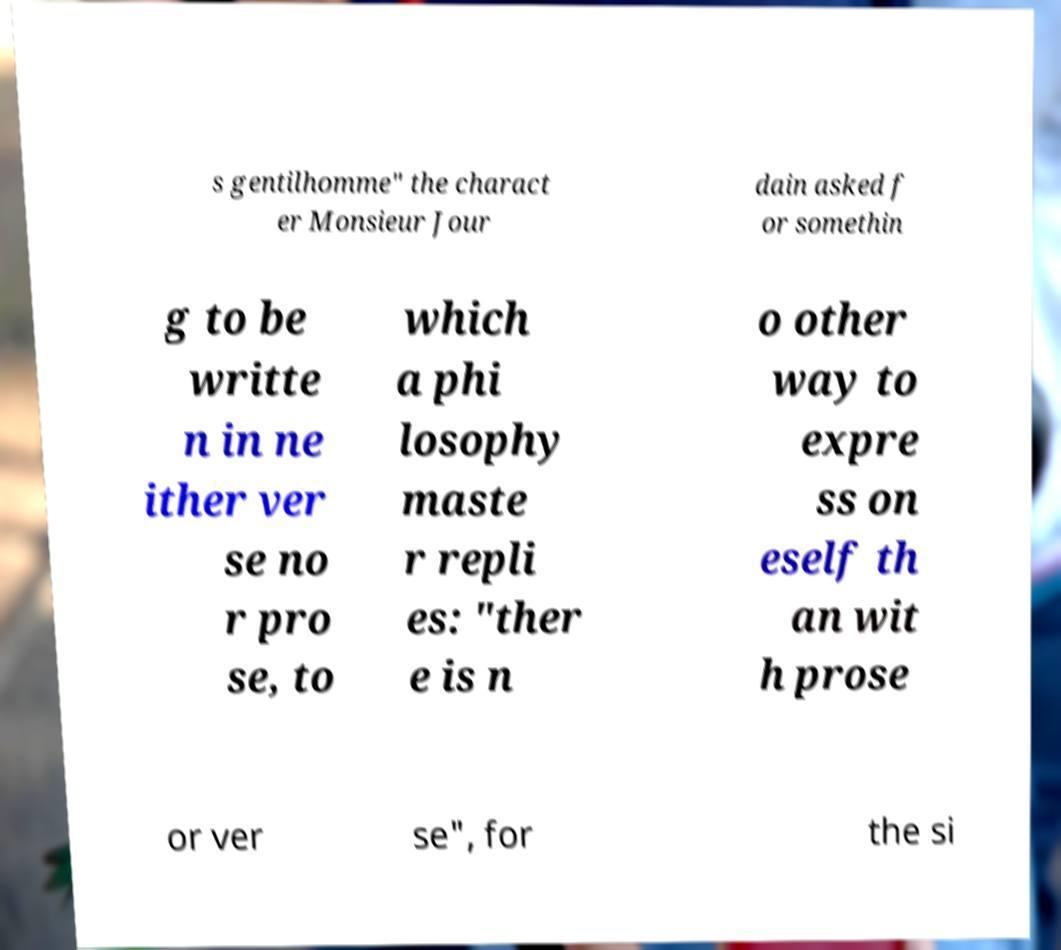I need the written content from this picture converted into text. Can you do that? s gentilhomme" the charact er Monsieur Jour dain asked f or somethin g to be writte n in ne ither ver se no r pro se, to which a phi losophy maste r repli es: "ther e is n o other way to expre ss on eself th an wit h prose or ver se", for the si 